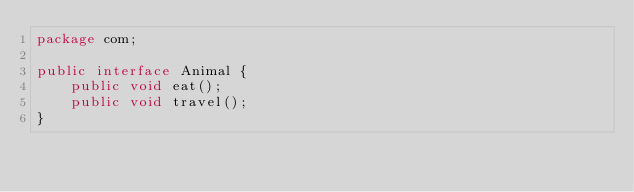Convert code to text. <code><loc_0><loc_0><loc_500><loc_500><_Java_>package com;

public interface Animal {
    public void eat();
    public void travel();
}
</code> 